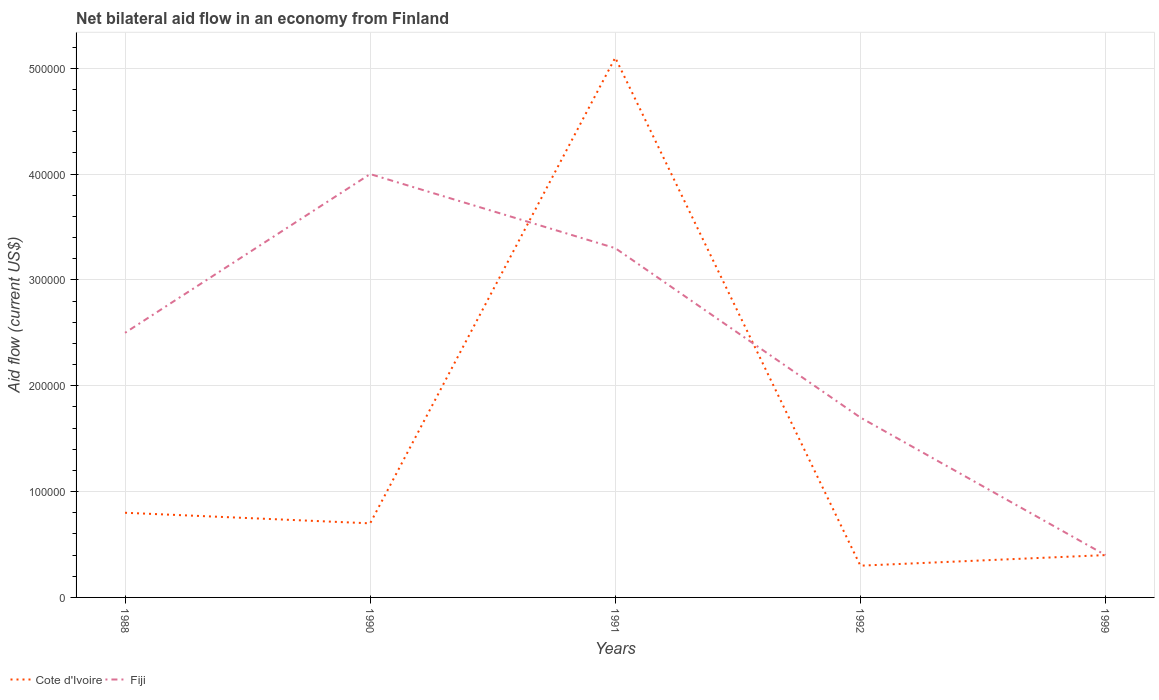How many different coloured lines are there?
Offer a terse response. 2. Does the line corresponding to Cote d'Ivoire intersect with the line corresponding to Fiji?
Offer a very short reply. Yes. Is the number of lines equal to the number of legend labels?
Ensure brevity in your answer.  Yes. Across all years, what is the maximum net bilateral aid flow in Cote d'Ivoire?
Your response must be concise. 3.00e+04. In which year was the net bilateral aid flow in Cote d'Ivoire maximum?
Your answer should be very brief. 1992. What is the total net bilateral aid flow in Cote d'Ivoire in the graph?
Provide a short and direct response. -10000. What is the difference between the highest and the second highest net bilateral aid flow in Fiji?
Ensure brevity in your answer.  3.60e+05. What is the difference between the highest and the lowest net bilateral aid flow in Cote d'Ivoire?
Provide a short and direct response. 1. Is the net bilateral aid flow in Fiji strictly greater than the net bilateral aid flow in Cote d'Ivoire over the years?
Make the answer very short. No. What is the title of the graph?
Give a very brief answer. Net bilateral aid flow in an economy from Finland. Does "Vanuatu" appear as one of the legend labels in the graph?
Give a very brief answer. No. What is the label or title of the Y-axis?
Make the answer very short. Aid flow (current US$). What is the Aid flow (current US$) in Cote d'Ivoire in 1990?
Make the answer very short. 7.00e+04. What is the Aid flow (current US$) in Fiji in 1990?
Give a very brief answer. 4.00e+05. What is the Aid flow (current US$) of Cote d'Ivoire in 1991?
Provide a short and direct response. 5.10e+05. What is the Aid flow (current US$) in Cote d'Ivoire in 1992?
Your answer should be very brief. 3.00e+04. What is the Aid flow (current US$) in Fiji in 1992?
Provide a short and direct response. 1.70e+05. What is the Aid flow (current US$) in Cote d'Ivoire in 1999?
Your answer should be compact. 4.00e+04. What is the Aid flow (current US$) in Fiji in 1999?
Your answer should be very brief. 4.00e+04. Across all years, what is the maximum Aid flow (current US$) of Cote d'Ivoire?
Offer a very short reply. 5.10e+05. Across all years, what is the maximum Aid flow (current US$) in Fiji?
Offer a terse response. 4.00e+05. Across all years, what is the minimum Aid flow (current US$) in Fiji?
Your answer should be very brief. 4.00e+04. What is the total Aid flow (current US$) in Cote d'Ivoire in the graph?
Offer a very short reply. 7.30e+05. What is the total Aid flow (current US$) in Fiji in the graph?
Provide a short and direct response. 1.19e+06. What is the difference between the Aid flow (current US$) in Cote d'Ivoire in 1988 and that in 1990?
Ensure brevity in your answer.  10000. What is the difference between the Aid flow (current US$) in Fiji in 1988 and that in 1990?
Provide a short and direct response. -1.50e+05. What is the difference between the Aid flow (current US$) in Cote d'Ivoire in 1988 and that in 1991?
Give a very brief answer. -4.30e+05. What is the difference between the Aid flow (current US$) in Fiji in 1988 and that in 1991?
Your response must be concise. -8.00e+04. What is the difference between the Aid flow (current US$) in Cote d'Ivoire in 1990 and that in 1991?
Provide a short and direct response. -4.40e+05. What is the difference between the Aid flow (current US$) of Fiji in 1990 and that in 1992?
Your answer should be very brief. 2.30e+05. What is the difference between the Aid flow (current US$) of Fiji in 1990 and that in 1999?
Offer a terse response. 3.60e+05. What is the difference between the Aid flow (current US$) in Cote d'Ivoire in 1991 and that in 1992?
Keep it short and to the point. 4.80e+05. What is the difference between the Aid flow (current US$) of Cote d'Ivoire in 1991 and that in 1999?
Provide a short and direct response. 4.70e+05. What is the difference between the Aid flow (current US$) of Fiji in 1991 and that in 1999?
Offer a very short reply. 2.90e+05. What is the difference between the Aid flow (current US$) in Cote d'Ivoire in 1988 and the Aid flow (current US$) in Fiji in 1990?
Offer a very short reply. -3.20e+05. What is the difference between the Aid flow (current US$) of Cote d'Ivoire in 1988 and the Aid flow (current US$) of Fiji in 1992?
Your response must be concise. -9.00e+04. What is the difference between the Aid flow (current US$) in Cote d'Ivoire in 1990 and the Aid flow (current US$) in Fiji in 1992?
Give a very brief answer. -1.00e+05. What is the difference between the Aid flow (current US$) in Cote d'Ivoire in 1991 and the Aid flow (current US$) in Fiji in 1999?
Offer a terse response. 4.70e+05. What is the difference between the Aid flow (current US$) in Cote d'Ivoire in 1992 and the Aid flow (current US$) in Fiji in 1999?
Your answer should be very brief. -10000. What is the average Aid flow (current US$) in Cote d'Ivoire per year?
Provide a succinct answer. 1.46e+05. What is the average Aid flow (current US$) of Fiji per year?
Provide a short and direct response. 2.38e+05. In the year 1990, what is the difference between the Aid flow (current US$) of Cote d'Ivoire and Aid flow (current US$) of Fiji?
Ensure brevity in your answer.  -3.30e+05. In the year 1992, what is the difference between the Aid flow (current US$) in Cote d'Ivoire and Aid flow (current US$) in Fiji?
Provide a short and direct response. -1.40e+05. In the year 1999, what is the difference between the Aid flow (current US$) of Cote d'Ivoire and Aid flow (current US$) of Fiji?
Your response must be concise. 0. What is the ratio of the Aid flow (current US$) in Fiji in 1988 to that in 1990?
Your answer should be compact. 0.62. What is the ratio of the Aid flow (current US$) of Cote d'Ivoire in 1988 to that in 1991?
Give a very brief answer. 0.16. What is the ratio of the Aid flow (current US$) in Fiji in 1988 to that in 1991?
Your answer should be compact. 0.76. What is the ratio of the Aid flow (current US$) of Cote d'Ivoire in 1988 to that in 1992?
Ensure brevity in your answer.  2.67. What is the ratio of the Aid flow (current US$) of Fiji in 1988 to that in 1992?
Your answer should be very brief. 1.47. What is the ratio of the Aid flow (current US$) of Cote d'Ivoire in 1988 to that in 1999?
Your answer should be compact. 2. What is the ratio of the Aid flow (current US$) in Fiji in 1988 to that in 1999?
Your answer should be compact. 6.25. What is the ratio of the Aid flow (current US$) in Cote d'Ivoire in 1990 to that in 1991?
Offer a very short reply. 0.14. What is the ratio of the Aid flow (current US$) of Fiji in 1990 to that in 1991?
Ensure brevity in your answer.  1.21. What is the ratio of the Aid flow (current US$) in Cote d'Ivoire in 1990 to that in 1992?
Offer a terse response. 2.33. What is the ratio of the Aid flow (current US$) of Fiji in 1990 to that in 1992?
Provide a short and direct response. 2.35. What is the ratio of the Aid flow (current US$) of Cote d'Ivoire in 1990 to that in 1999?
Your answer should be very brief. 1.75. What is the ratio of the Aid flow (current US$) of Fiji in 1991 to that in 1992?
Ensure brevity in your answer.  1.94. What is the ratio of the Aid flow (current US$) in Cote d'Ivoire in 1991 to that in 1999?
Provide a succinct answer. 12.75. What is the ratio of the Aid flow (current US$) of Fiji in 1991 to that in 1999?
Offer a terse response. 8.25. What is the ratio of the Aid flow (current US$) of Fiji in 1992 to that in 1999?
Offer a very short reply. 4.25. What is the difference between the highest and the second highest Aid flow (current US$) in Fiji?
Your response must be concise. 7.00e+04. What is the difference between the highest and the lowest Aid flow (current US$) in Fiji?
Your response must be concise. 3.60e+05. 